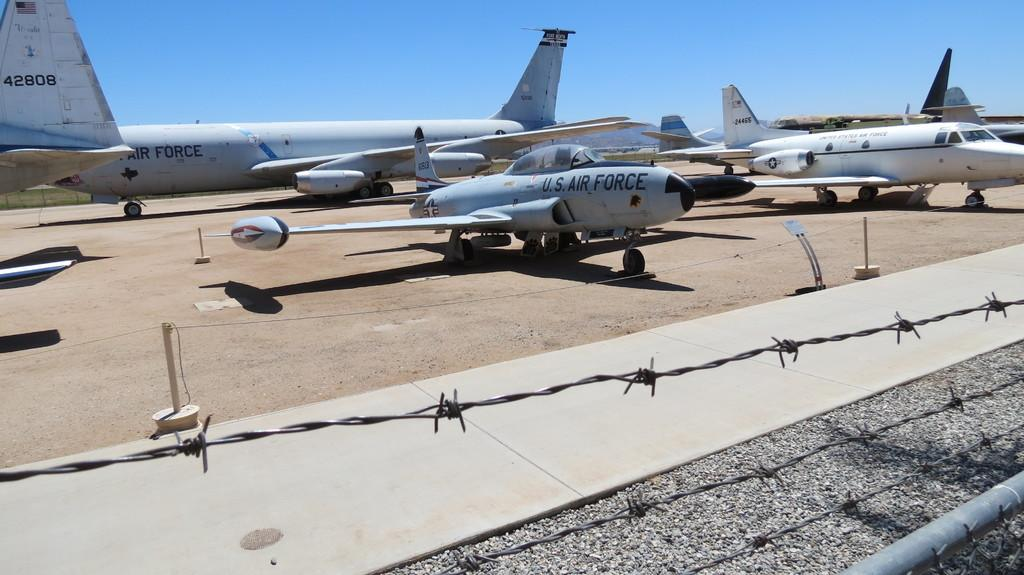<image>
Present a compact description of the photo's key features. air force planes are lined up behind barbed wire 